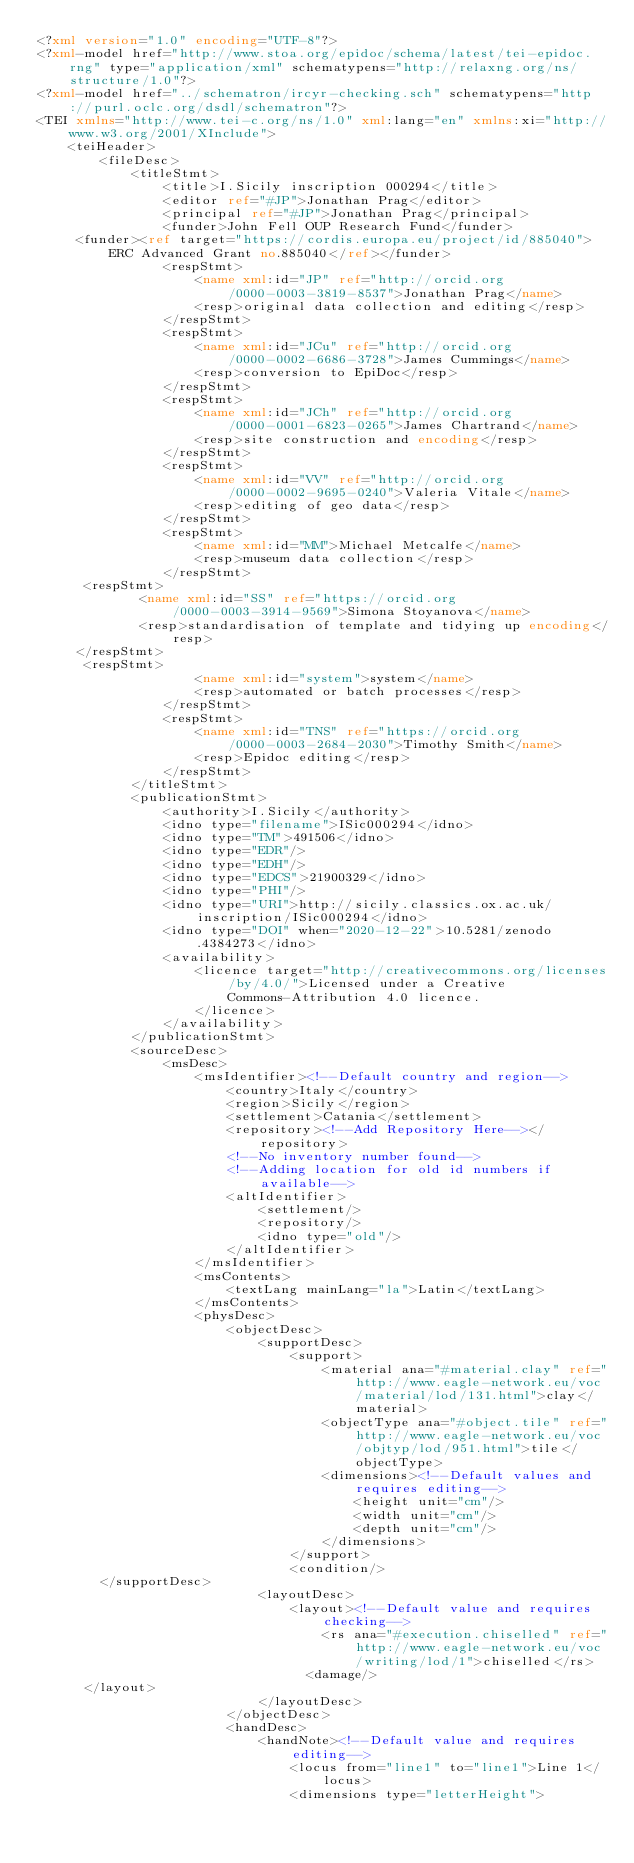<code> <loc_0><loc_0><loc_500><loc_500><_XML_><?xml version="1.0" encoding="UTF-8"?>
<?xml-model href="http://www.stoa.org/epidoc/schema/latest/tei-epidoc.rng" type="application/xml" schematypens="http://relaxng.org/ns/structure/1.0"?>
<?xml-model href="../schematron/ircyr-checking.sch" schematypens="http://purl.oclc.org/dsdl/schematron"?>                                                
<TEI xmlns="http://www.tei-c.org/ns/1.0" xml:lang="en" xmlns:xi="http://www.w3.org/2001/XInclude">
    <teiHeader>
        <fileDesc>
            <titleStmt>
                <title>I.Sicily inscription 000294</title>
                <editor ref="#JP">Jonathan Prag</editor>
                <principal ref="#JP">Jonathan Prag</principal>
                <funder>John Fell OUP Research Fund</funder>
	   <funder><ref target="https://cordis.europa.eu/project/id/885040">ERC Advanced Grant no.885040</ref></funder>
                <respStmt>
                    <name xml:id="JP" ref="http://orcid.org/0000-0003-3819-8537">Jonathan Prag</name>
                    <resp>original data collection and editing</resp>
                </respStmt>
                <respStmt>
                    <name xml:id="JCu" ref="http://orcid.org/0000-0002-6686-3728">James Cummings</name>
                    <resp>conversion to EpiDoc</resp>
                </respStmt>
                <respStmt>
                    <name xml:id="JCh" ref="http://orcid.org/0000-0001-6823-0265">James Chartrand</name>
                    <resp>site construction and encoding</resp>
                </respStmt>
                <respStmt>
                    <name xml:id="VV" ref="http://orcid.org/0000-0002-9695-0240">Valeria Vitale</name>
                    <resp>editing of geo data</resp>
                </respStmt>
                <respStmt>
                    <name xml:id="MM">Michael Metcalfe</name>
                    <resp>museum data collection</resp>
                </respStmt>
	    <respStmt>
     	       <name xml:id="SS" ref="https://orcid.org/0000-0003-3914-9569">Simona Stoyanova</name>
     	       <resp>standardisation of template and tidying up encoding</resp>
 	   </respStmt>
	    <respStmt>
                    <name xml:id="system">system</name>
                    <resp>automated or batch processes</resp>
                </respStmt>
                <respStmt>
                    <name xml:id="TNS" ref="https://orcid.org/0000-0003-2684-2030">Timothy Smith</name>
                    <resp>Epidoc editing</resp>
                </respStmt>
            </titleStmt>
            <publicationStmt>
                <authority>I.Sicily</authority>
                <idno type="filename">ISic000294</idno>
                <idno type="TM">491506</idno>
                <idno type="EDR"/>
                <idno type="EDH"/>
                <idno type="EDCS">21900329</idno>
                <idno type="PHI"/>
                <idno type="URI">http://sicily.classics.ox.ac.uk/inscription/ISic000294</idno>
                <idno type="DOI" when="2020-12-22">10.5281/zenodo.4384273</idno>
                <availability>
                    <licence target="http://creativecommons.org/licenses/by/4.0/">Licensed under a Creative
                        Commons-Attribution 4.0 licence.
                    </licence>
                </availability>
            </publicationStmt>
            <sourceDesc>
                <msDesc>
                    <msIdentifier><!--Default country and region-->
                        <country>Italy</country>
                        <region>Sicily</region>
                        <settlement>Catania</settlement>
                        <repository><!--Add Repository Here--></repository>
                        <!--No inventory number found-->
                        <!--Adding location for old id numbers if available-->
                        <altIdentifier>
                            <settlement/>
                            <repository/>
                            <idno type="old"/>
                        </altIdentifier>
                    </msIdentifier>
                    <msContents>
                        <textLang mainLang="la">Latin</textLang>
                    </msContents>
                    <physDesc>
                        <objectDesc>
                            <supportDesc>
                                <support>
                                    <material ana="#material.clay" ref="http://www.eagle-network.eu/voc/material/lod/131.html">clay</material>
                                    <objectType ana="#object.tile" ref="http://www.eagle-network.eu/voc/objtyp/lod/951.html">tile</objectType>
                                    <dimensions><!--Default values and requires editing-->
                                        <height unit="cm"/>
                                        <width unit="cm"/>
                                        <depth unit="cm"/>
                                    </dimensions>
                                </support>
                                <condition/>
		    </supportDesc>
                            <layoutDesc>
                                <layout><!--Default value and requires checking-->
                                    <rs ana="#execution.chiselled" ref="http://www.eagle-network.eu/voc/writing/lod/1">chiselled</rs>
                                	<damage/>
			</layout>
                            </layoutDesc>
                        </objectDesc>
                        <handDesc>
                            <handNote><!--Default value and requires editing-->
                                <locus from="line1" to="line1">Line 1</locus>
                                <dimensions type="letterHeight"></code> 